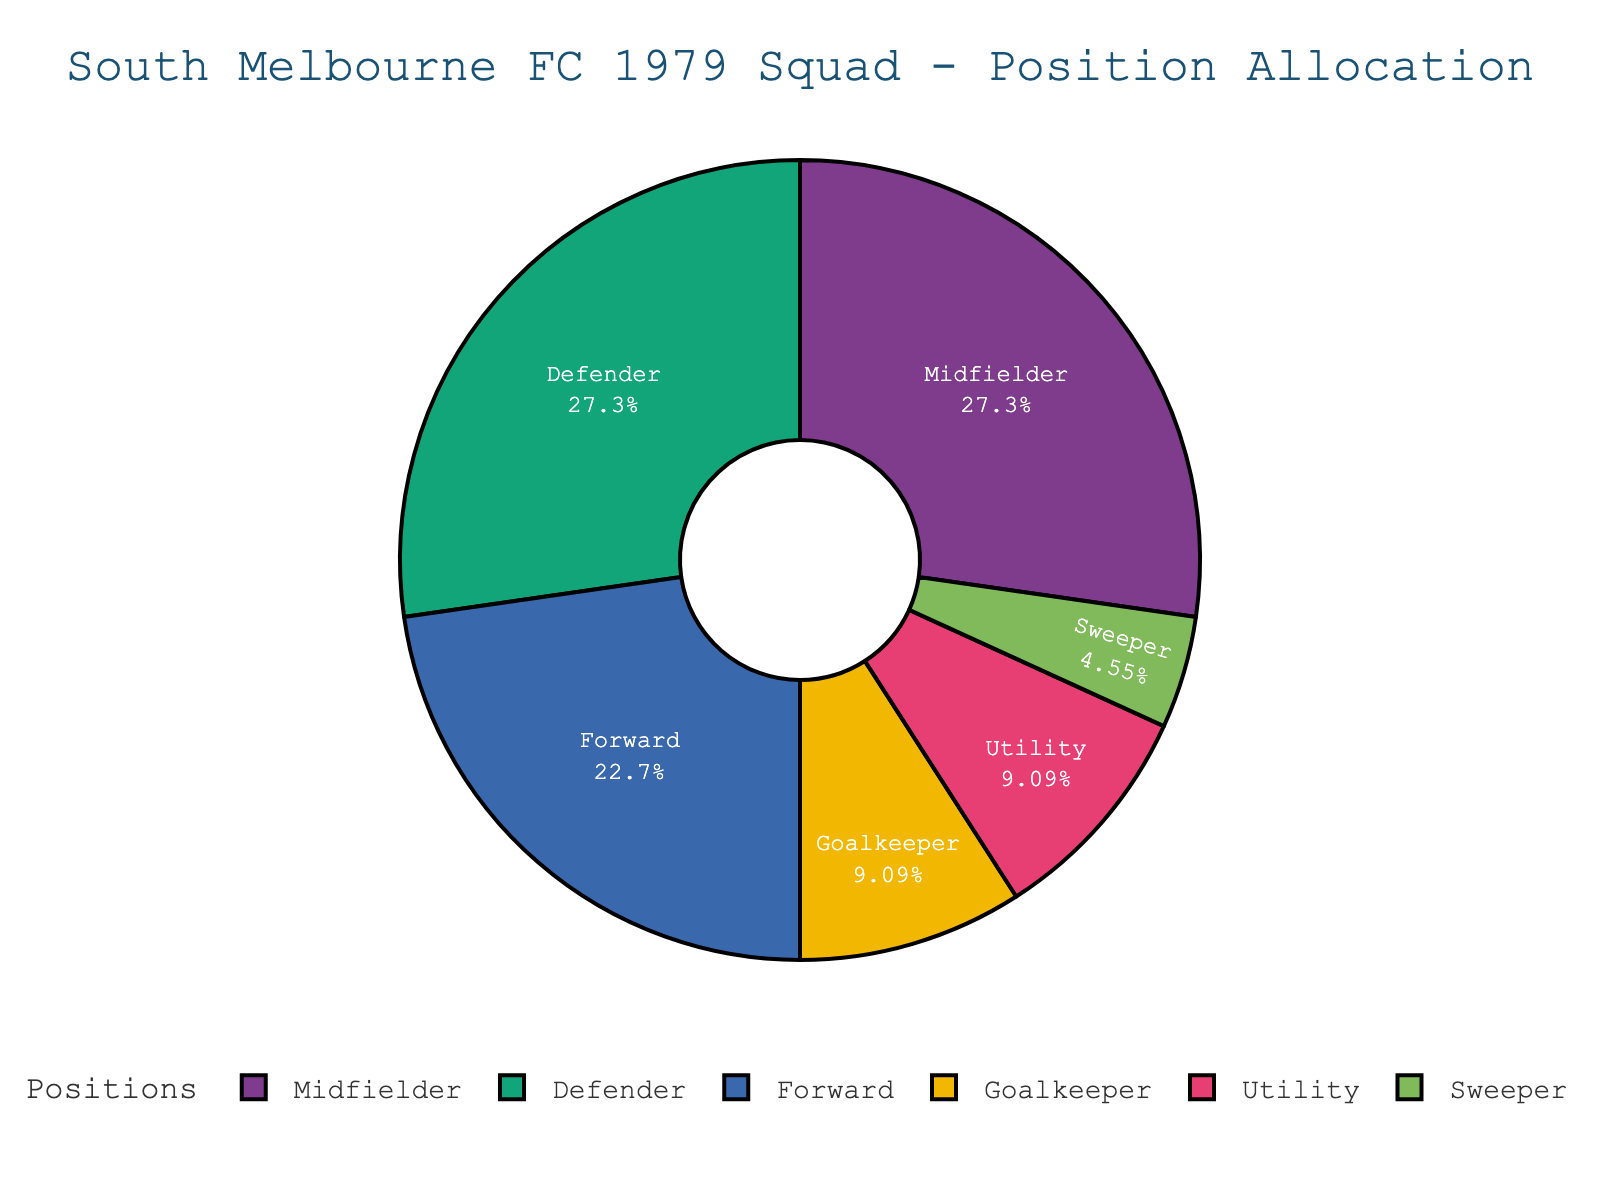How many more midfielders and defenders combined are there than forwards? First, add the number of midfielders and defenders: 6 + 6 = 12. Then subtract the number of forwards: 12 - 5 = 7. So, there are 7 more midfielders and defenders combined than forwards.
Answer: 7 Which position represents the smallest portion of the squad? By inspecting the pie chart, the sweeper position has the smallest segment.
Answer: Sweeper What percentage of the squad do goalkeepers and utility players together represent? Add the number of goalkeepers and utility players: 2 + 2 = 4. Then find the total number of players: 5 + 6 + 6 + 2 + 2 + 1 = 22. Calculate the percentage: (4 / 22) * 100 ≈ 18.18%.
Answer: 18.18% Is there an equal number of defenders and midfielders? Yes, both the defenders and midfielders segments in the pie chart are equal, representing the same number of players.
Answer: Yes Which position has the same number of players as the forwards? By examining the pie chart, there is no other position that has 5 players like the forwards.
Answer: None What is the combined percentage of players in forward and goalkeeper positions? Add the number of forwards and goalkeepers: 5 + 2 = 7. Then compute the percentage out of the total 22 players: (7 / 22) * 100 ≈ 31.82%.
Answer: 31.82% How does the number of utility players compare to the number of sweepers? There are 2 utility players and 1 sweeper, so there are twice as many utility players as sweepers.
Answer: Twice What visual feature indicates the most common playing position in the team? The largest segment in the pie chart represents the midfielders, indicating it is the most common position.
Answer: Largest segment 